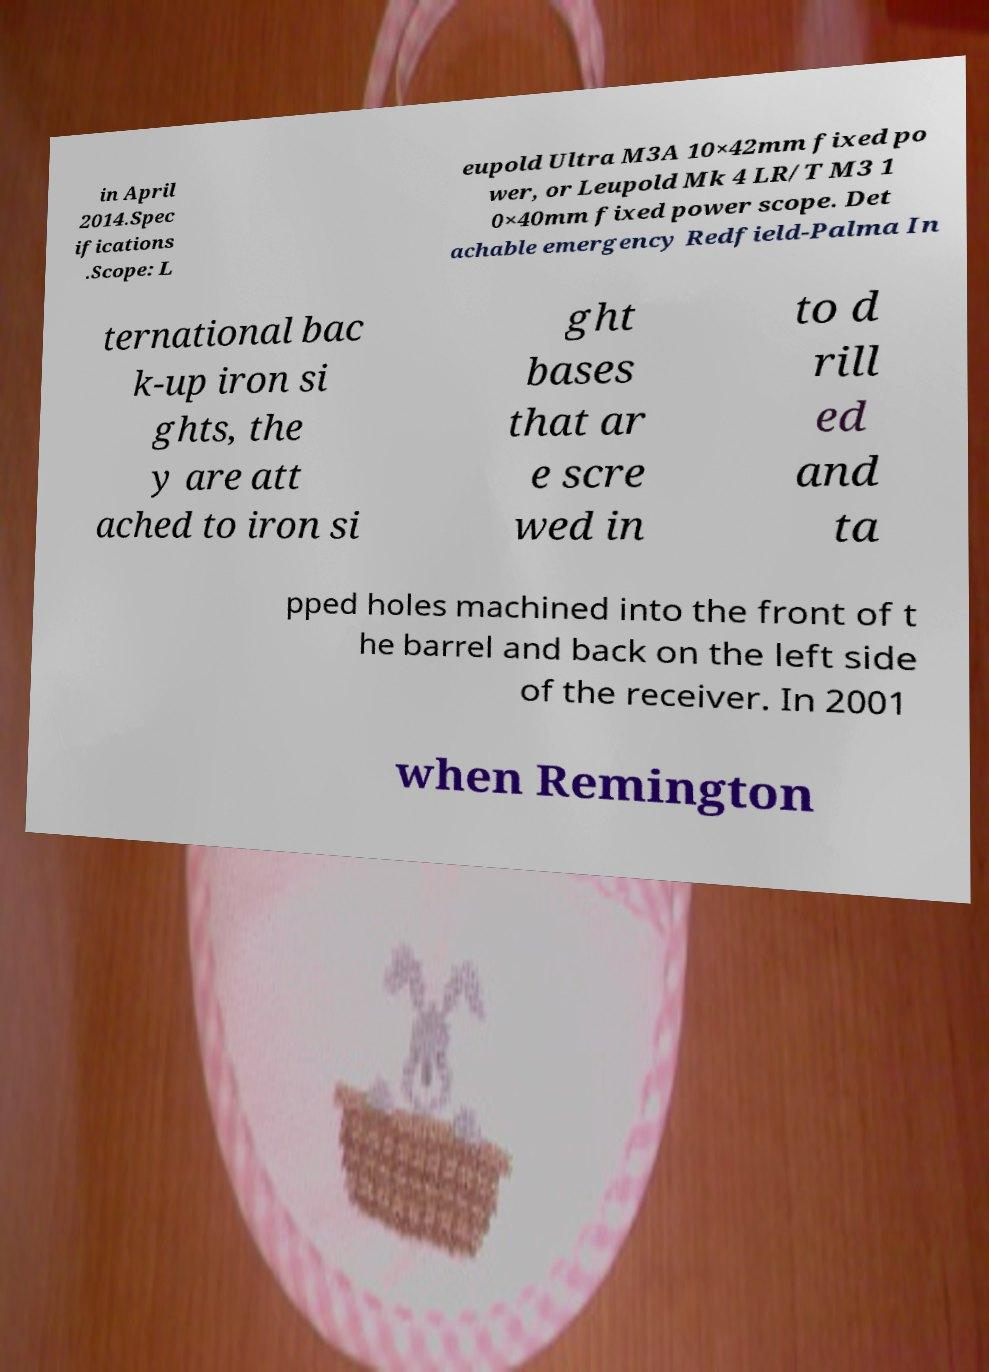Please read and relay the text visible in this image. What does it say? in April 2014.Spec ifications .Scope: L eupold Ultra M3A 10×42mm fixed po wer, or Leupold Mk 4 LR/T M3 1 0×40mm fixed power scope. Det achable emergency Redfield-Palma In ternational bac k-up iron si ghts, the y are att ached to iron si ght bases that ar e scre wed in to d rill ed and ta pped holes machined into the front of t he barrel and back on the left side of the receiver. In 2001 when Remington 